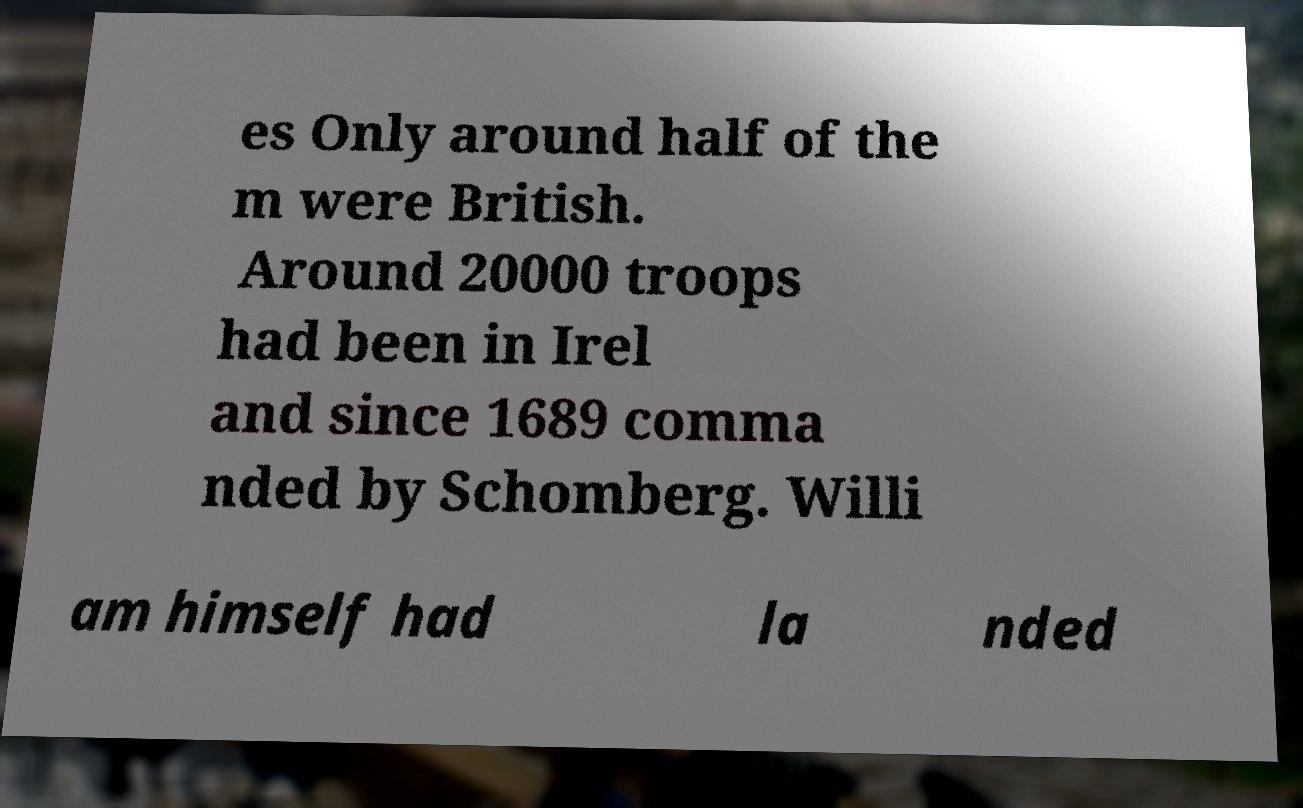Could you extract and type out the text from this image? es Only around half of the m were British. Around 20000 troops had been in Irel and since 1689 comma nded by Schomberg. Willi am himself had la nded 